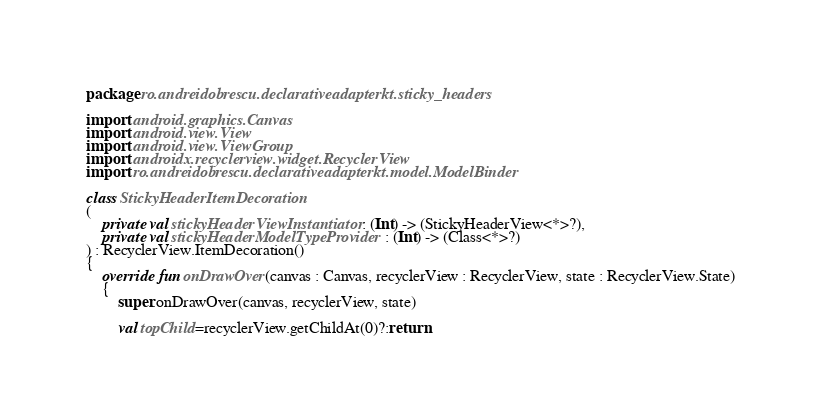Convert code to text. <code><loc_0><loc_0><loc_500><loc_500><_Kotlin_>package ro.andreidobrescu.declarativeadapterkt.sticky_headers

import android.graphics.Canvas
import android.view.View
import android.view.ViewGroup
import androidx.recyclerview.widget.RecyclerView
import ro.andreidobrescu.declarativeadapterkt.model.ModelBinder

class StickyHeaderItemDecoration
(
    private val stickyHeaderViewInstantiator : (Int) -> (StickyHeaderView<*>?),
    private val stickyHeaderModelTypeProvider : (Int) -> (Class<*>?)
) : RecyclerView.ItemDecoration()
{
    override fun onDrawOver(canvas : Canvas, recyclerView : RecyclerView, state : RecyclerView.State)
    {
        super.onDrawOver(canvas, recyclerView, state)

        val topChild=recyclerView.getChildAt(0)?:return
</code> 